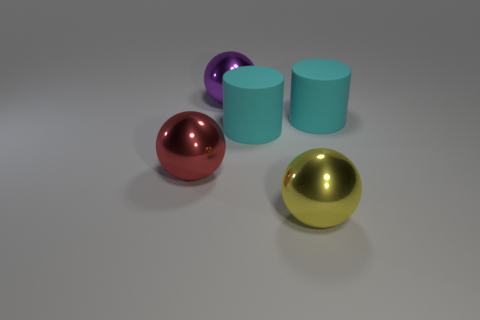There is a purple ball that is the same size as the yellow sphere; what material is it?
Offer a very short reply. Metal. Is the shape of the thing that is to the left of the big purple object the same as  the yellow thing?
Provide a short and direct response. Yes. How many things are either purple balls or metal balls that are to the left of the yellow object?
Your response must be concise. 2. Is the number of cyan things less than the number of large purple shiny objects?
Make the answer very short. No. Are there more big purple spheres than big matte cylinders?
Offer a terse response. No. What number of other objects are there of the same material as the red object?
Ensure brevity in your answer.  2. How many purple objects are behind the large thing on the left side of the large metallic sphere behind the red ball?
Provide a succinct answer. 1. How many rubber things are big cyan objects or spheres?
Ensure brevity in your answer.  2. There is a object that is left of the large shiny ball that is behind the large red thing; what size is it?
Your answer should be compact. Large. There is a matte cylinder right of the yellow ball; is it the same color as the big matte thing left of the yellow object?
Give a very brief answer. Yes. 